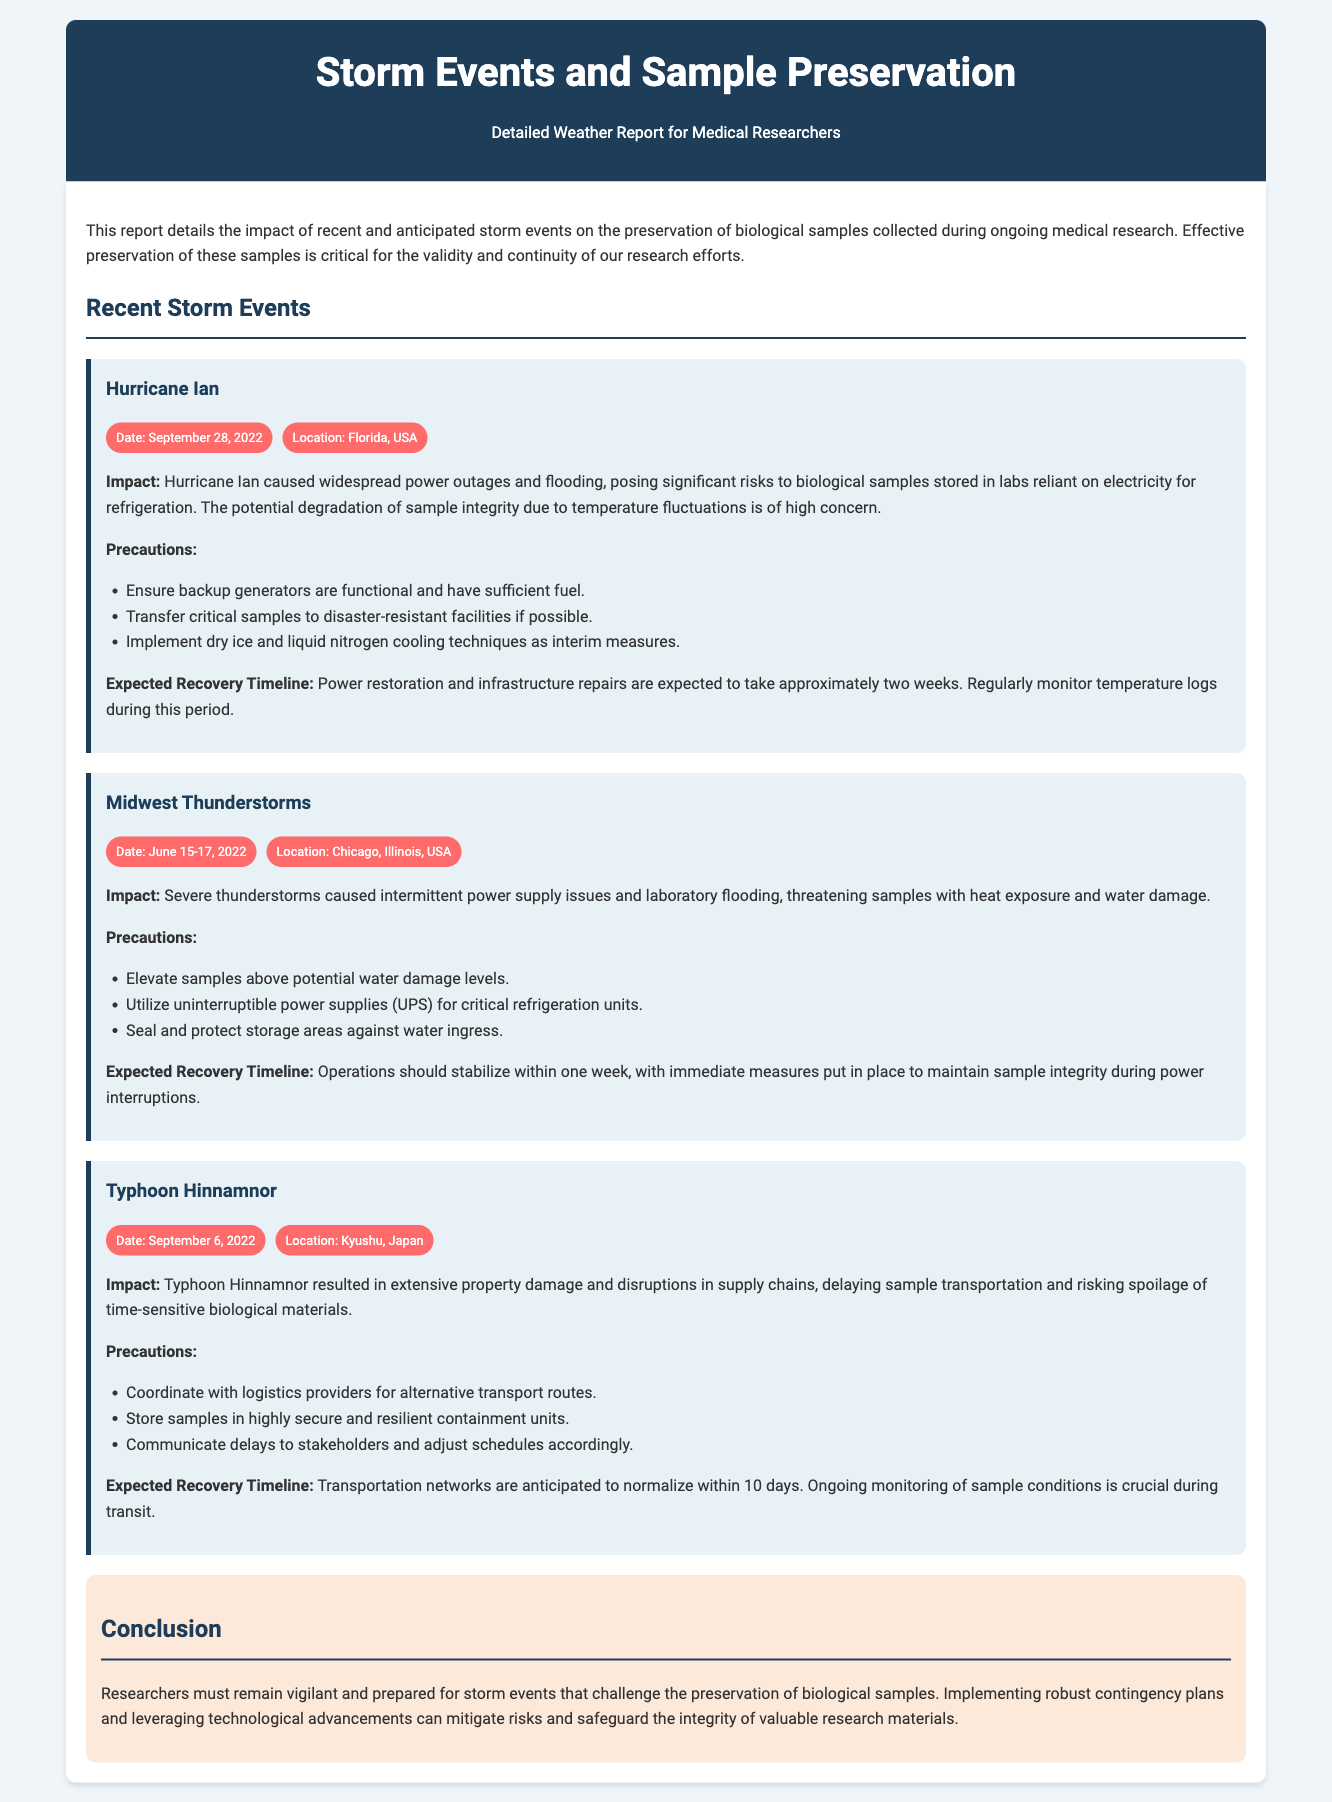what was the date of Hurricane Ian? The date of Hurricane Ian is specifically mentioned in the document as September 28, 2022.
Answer: September 28, 2022 what location was affected by the Midwest Thunderstorms? The location of the Midwest Thunderstorms is mentioned as Chicago, Illinois, USA in the document.
Answer: Chicago, Illinois, USA what is one precaution for the Hurricane Ian event? The document lists several precautions, one of which is to ensure backup generators are functional and have sufficient fuel.
Answer: Ensure backup generators are functional what is the expected recovery timeline for the Typhoon Hinnamnor? The expected recovery timeline for the Typhoon Hinnamnor is detailed as 10 days for transportation networks to normalize.
Answer: 10 days how long did the Midwest Thunderstorms impact operations? The document indicates that operations should stabilize within one week after the Midwest Thunderstorms.
Answer: One week what environmental risk is highlighted in the conclusion? The conclusion emphasizes the need for researchers to remain vigilant about storm events that challenge preservation of biological samples.
Answer: Storm events what is a potential risk posed by Hurricane Ian? One of the risks posed by Hurricane Ian is significant degradation of sample integrity due to temperature fluctuations.
Answer: Degradation of sample integrity what should researchers implement to mitigate risks? Researchers are advised to implement robust contingency plans as a precaution against storm events impacting their samples.
Answer: Robust contingency plans 